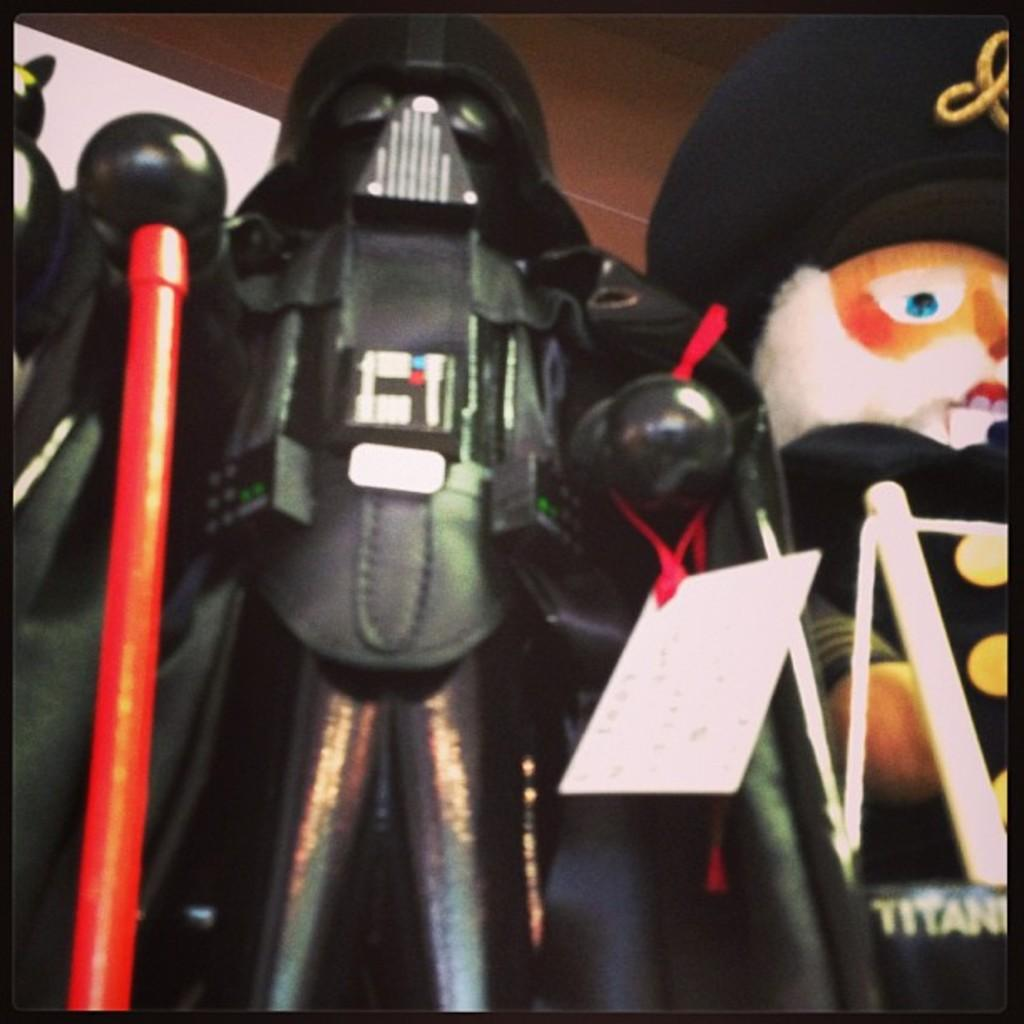What can be seen in the foreground of the image? There are two toys in the foreground of the image. Can you describe any specific details about the toys? One of the toys has a tag. What colors are present in the background of the image? The background of the image is brown and white. What type of brush is being used by the daughter in the image? There is no daughter present in the image. 